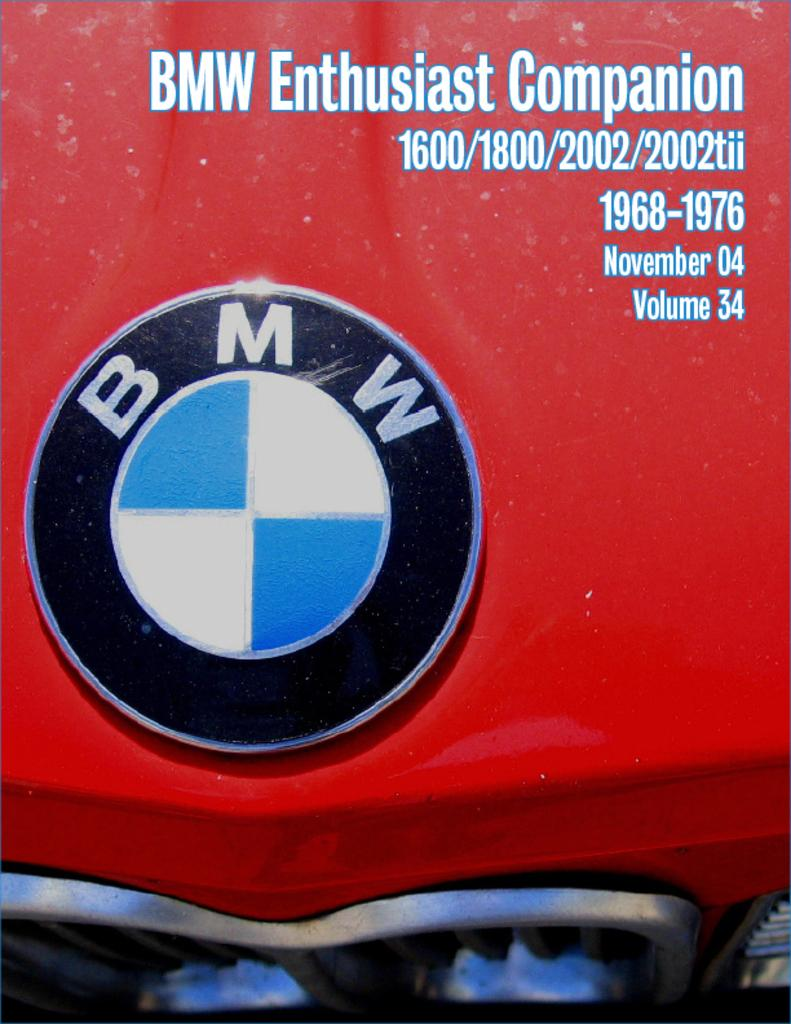What brand is represented by the logo in the image? The logo in the image is of BMW. What color is the surface on which the logo is placed? The logo is on a red color surface. Where can you find some text in the image? There is some text in the top right side of the image. What type of breakfast is being served in the image? There is no breakfast present in the image; it only features the BMW logo on a red surface and some text in the top right side. 